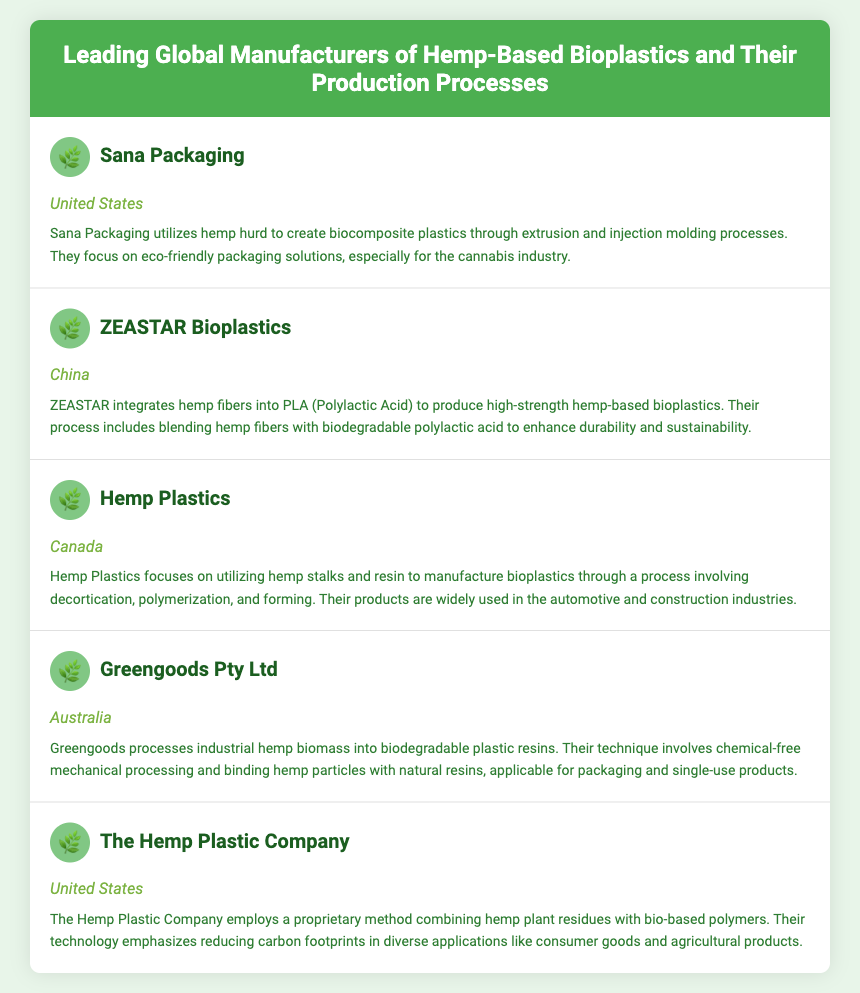What is the name of the manufacturer from the United States? The document lists "Sana Packaging" and "The Hemp Plastic Company" as manufacturers from the United States.
Answer: Sana Packaging What production process does Hemp Plastics use? Hemp Plastics uses decortication, polymerization, and forming processes to manufacture bioplastics.
Answer: Decortication, polymerization, and forming Which company integrates hemp fibers with PLA? The document states that ZEASTAR Bioplastics integrates hemp fibers into PLA to produce bioplastics.
Answer: ZEASTAR Bioplastics What country is Greengoods Pty Ltd located in? The location of Greengoods Pty Ltd is explicitly mentioned in the document as Australia.
Answer: Australia What focus area does Sana Packaging emphasize? The focus area of Sana Packaging is on eco-friendly packaging solutions, particularly for the cannabis industry.
Answer: Eco-friendly packaging solutions How does Greengoods process their hemp biomass? Greengoods processes their industrial hemp biomass through chemical-free mechanical processing.
Answer: Chemical-free mechanical processing Which manufacturer uses hemp stalks and resin? The document specifies that Hemp Plastics utilizes hemp stalks and resin for their bioplastics.
Answer: Hemp Plastics What does The Hemp Plastic Company emphasize in its technology? The Hemp Plastic Company emphasizes reducing carbon footprints in various applications.
Answer: Reducing carbon footprints 